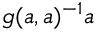<formula> <loc_0><loc_0><loc_500><loc_500>g ( a , a ) ^ { - 1 } a</formula> 